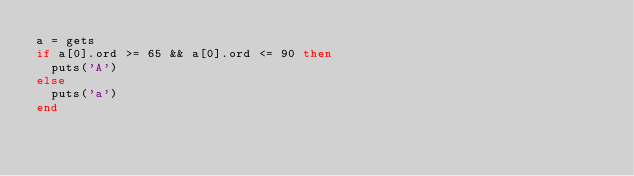Convert code to text. <code><loc_0><loc_0><loc_500><loc_500><_Ruby_>a = gets
if a[0].ord >= 65 && a[0].ord <= 90 then
  puts('A')
else
  puts('a')
end</code> 